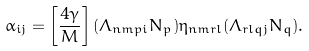Convert formula to latex. <formula><loc_0><loc_0><loc_500><loc_500>\alpha _ { i j } = \left [ \frac { 4 \gamma } { M } \right ] ( \Lambda _ { n m p i } N _ { p } ) \eta _ { n m r l } ( \Lambda _ { r l q j } N _ { q } ) .</formula> 